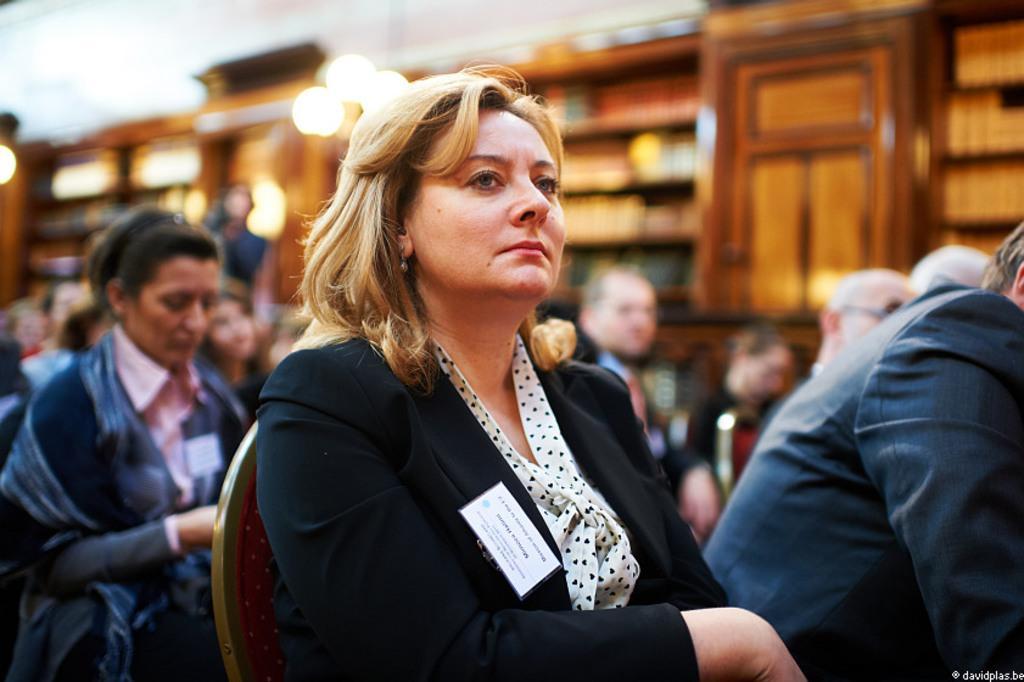Can you describe this image briefly? In this image, we can see people sitting on the chairs and some are wearing id cards. In the background, there are lights, cupboards and some other objects. At the bottom, there is some text. 